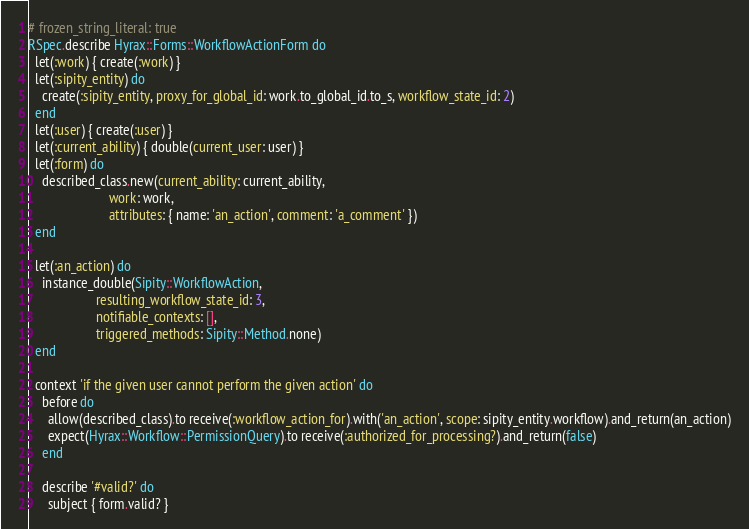<code> <loc_0><loc_0><loc_500><loc_500><_Ruby_># frozen_string_literal: true
RSpec.describe Hyrax::Forms::WorkflowActionForm do
  let(:work) { create(:work) }
  let(:sipity_entity) do
    create(:sipity_entity, proxy_for_global_id: work.to_global_id.to_s, workflow_state_id: 2)
  end
  let(:user) { create(:user) }
  let(:current_ability) { double(current_user: user) }
  let(:form) do
    described_class.new(current_ability: current_ability,
                        work: work,
                        attributes: { name: 'an_action', comment: 'a_comment' })
  end

  let(:an_action) do
    instance_double(Sipity::WorkflowAction,
                    resulting_workflow_state_id: 3,
                    notifiable_contexts: [],
                    triggered_methods: Sipity::Method.none)
  end

  context 'if the given user cannot perform the given action' do
    before do
      allow(described_class).to receive(:workflow_action_for).with('an_action', scope: sipity_entity.workflow).and_return(an_action)
      expect(Hyrax::Workflow::PermissionQuery).to receive(:authorized_for_processing?).and_return(false)
    end

    describe '#valid?' do
      subject { form.valid? }
</code> 